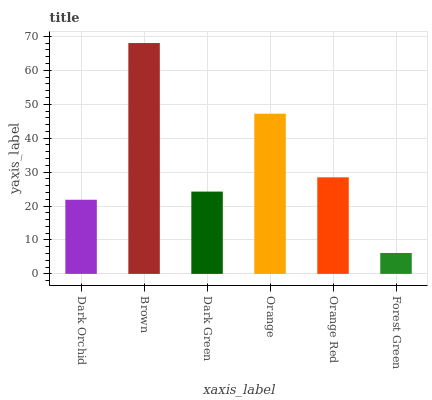Is Brown the maximum?
Answer yes or no. Yes. Is Dark Green the minimum?
Answer yes or no. No. Is Dark Green the maximum?
Answer yes or no. No. Is Brown greater than Dark Green?
Answer yes or no. Yes. Is Dark Green less than Brown?
Answer yes or no. Yes. Is Dark Green greater than Brown?
Answer yes or no. No. Is Brown less than Dark Green?
Answer yes or no. No. Is Orange Red the high median?
Answer yes or no. Yes. Is Dark Green the low median?
Answer yes or no. Yes. Is Dark Orchid the high median?
Answer yes or no. No. Is Orange the low median?
Answer yes or no. No. 